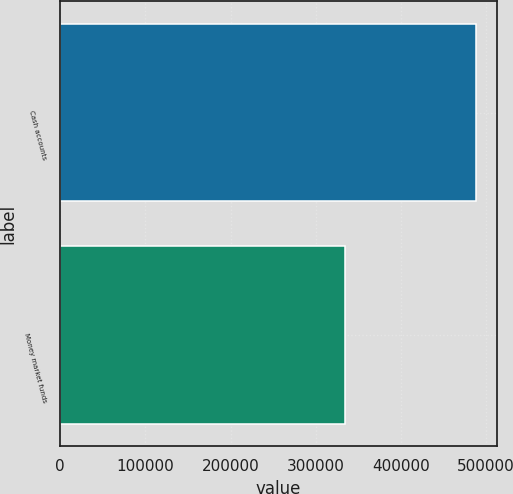<chart> <loc_0><loc_0><loc_500><loc_500><bar_chart><fcel>Cash accounts<fcel>Money market funds<nl><fcel>488504<fcel>333975<nl></chart> 